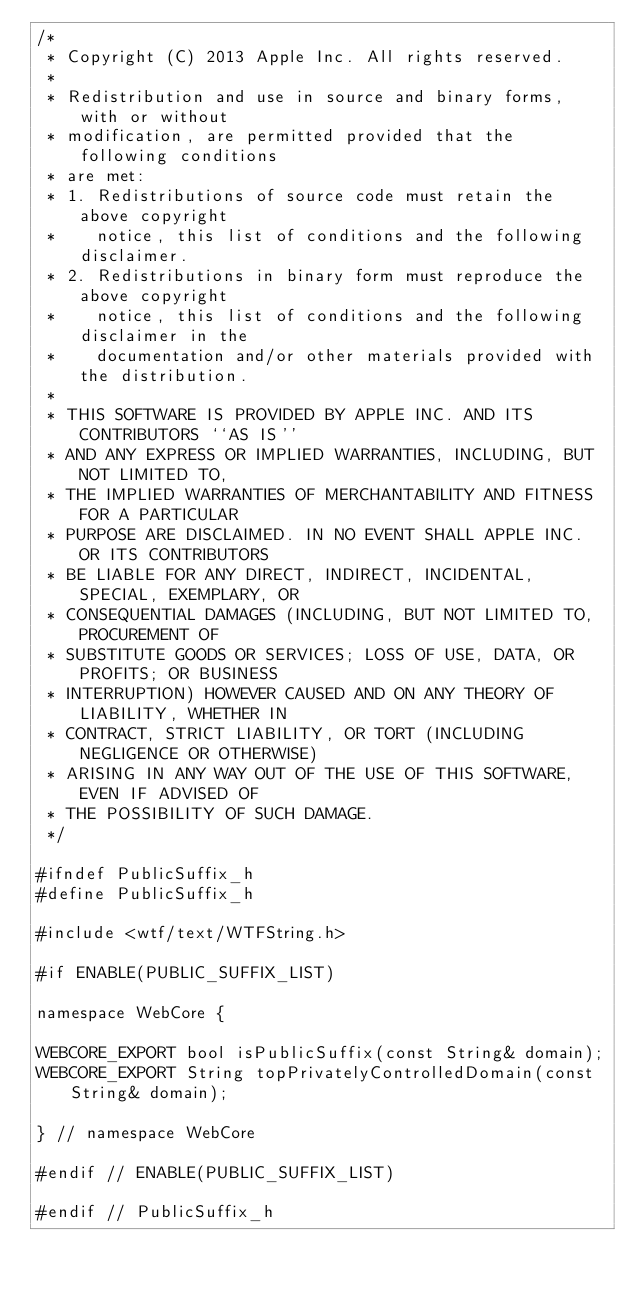Convert code to text. <code><loc_0><loc_0><loc_500><loc_500><_C_>/*
 * Copyright (C) 2013 Apple Inc. All rights reserved.
 *
 * Redistribution and use in source and binary forms, with or without
 * modification, are permitted provided that the following conditions
 * are met:
 * 1. Redistributions of source code must retain the above copyright
 *    notice, this list of conditions and the following disclaimer.
 * 2. Redistributions in binary form must reproduce the above copyright
 *    notice, this list of conditions and the following disclaimer in the
 *    documentation and/or other materials provided with the distribution.
 *
 * THIS SOFTWARE IS PROVIDED BY APPLE INC. AND ITS CONTRIBUTORS ``AS IS''
 * AND ANY EXPRESS OR IMPLIED WARRANTIES, INCLUDING, BUT NOT LIMITED TO,
 * THE IMPLIED WARRANTIES OF MERCHANTABILITY AND FITNESS FOR A PARTICULAR
 * PURPOSE ARE DISCLAIMED. IN NO EVENT SHALL APPLE INC. OR ITS CONTRIBUTORS
 * BE LIABLE FOR ANY DIRECT, INDIRECT, INCIDENTAL, SPECIAL, EXEMPLARY, OR
 * CONSEQUENTIAL DAMAGES (INCLUDING, BUT NOT LIMITED TO, PROCUREMENT OF
 * SUBSTITUTE GOODS OR SERVICES; LOSS OF USE, DATA, OR PROFITS; OR BUSINESS
 * INTERRUPTION) HOWEVER CAUSED AND ON ANY THEORY OF LIABILITY, WHETHER IN
 * CONTRACT, STRICT LIABILITY, OR TORT (INCLUDING NEGLIGENCE OR OTHERWISE)
 * ARISING IN ANY WAY OUT OF THE USE OF THIS SOFTWARE, EVEN IF ADVISED OF
 * THE POSSIBILITY OF SUCH DAMAGE.
 */

#ifndef PublicSuffix_h
#define PublicSuffix_h

#include <wtf/text/WTFString.h>

#if ENABLE(PUBLIC_SUFFIX_LIST)

namespace WebCore {

WEBCORE_EXPORT bool isPublicSuffix(const String& domain);
WEBCORE_EXPORT String topPrivatelyControlledDomain(const String& domain);

} // namespace WebCore

#endif // ENABLE(PUBLIC_SUFFIX_LIST)

#endif // PublicSuffix_h
</code> 